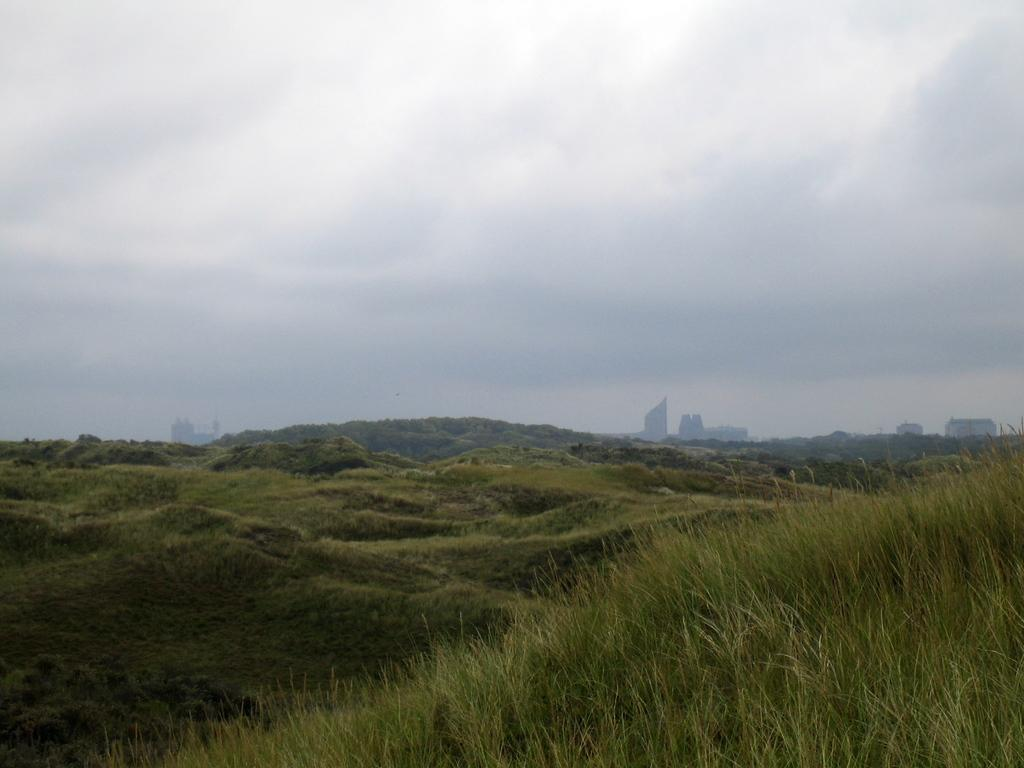What is the dominant color of the land in the image? The land in the image is covered with green grass. What type of terrain can be seen in the image? There are hills visible in the image. What is the condition of the sky in the image? The sky is cloudy in the image. How many toes can be seen on the tiger in the image? There is no tiger present in the image. What type of picture is being described in the image? The image itself is not a picture; it is a scene or landscape. 